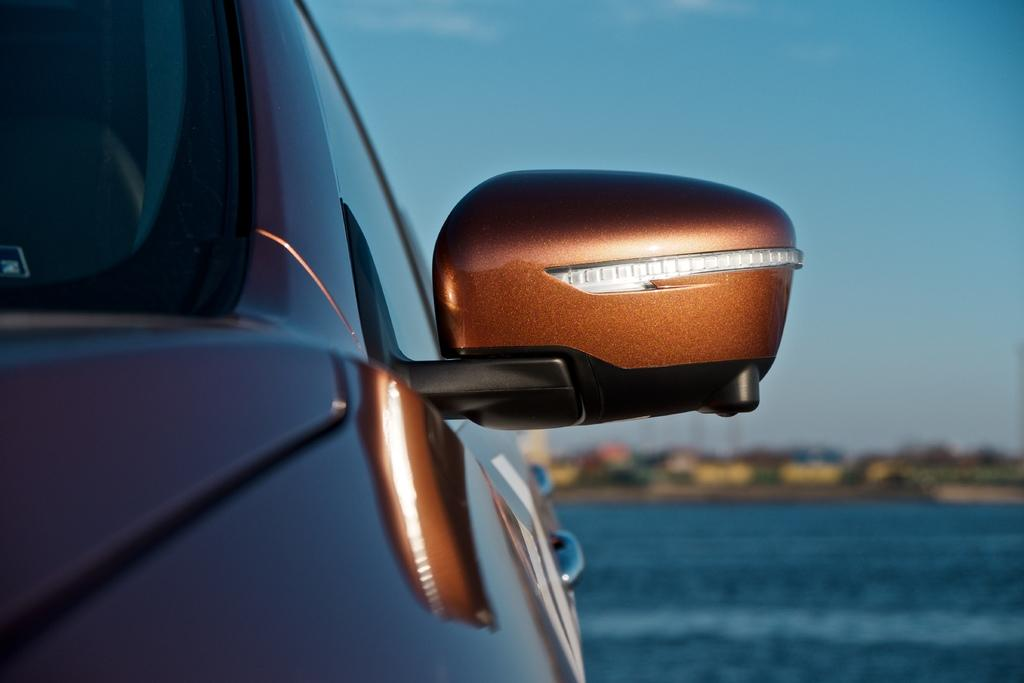What vehicle is located on the left side of the image? There is a car on the left side of the image. What part of the car is visible in the image? The side mirror and the side face of the car are visible. What can be seen in the background of the image? The background of the image is blurred, but a road, trees, and the sky are visible. How much money is being exchanged between the players in the basketball game in the image? There is no basketball game or money exchange present in the image; it features a car with a blurred background. 